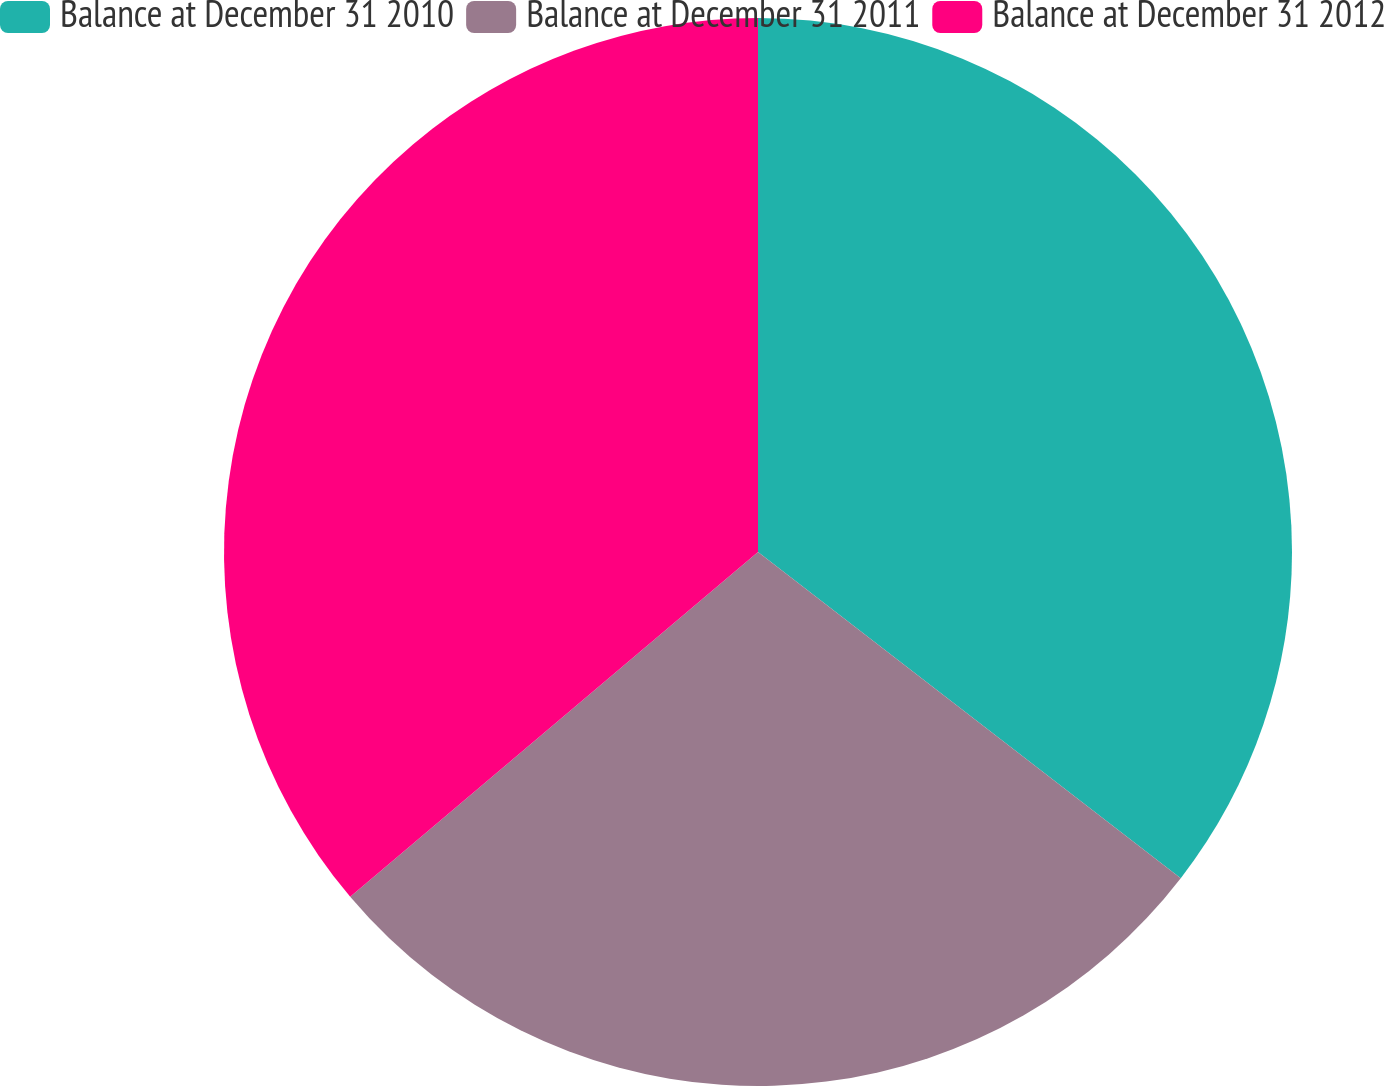<chart> <loc_0><loc_0><loc_500><loc_500><pie_chart><fcel>Balance at December 31 2010<fcel>Balance at December 31 2011<fcel>Balance at December 31 2012<nl><fcel>35.46%<fcel>28.37%<fcel>36.17%<nl></chart> 